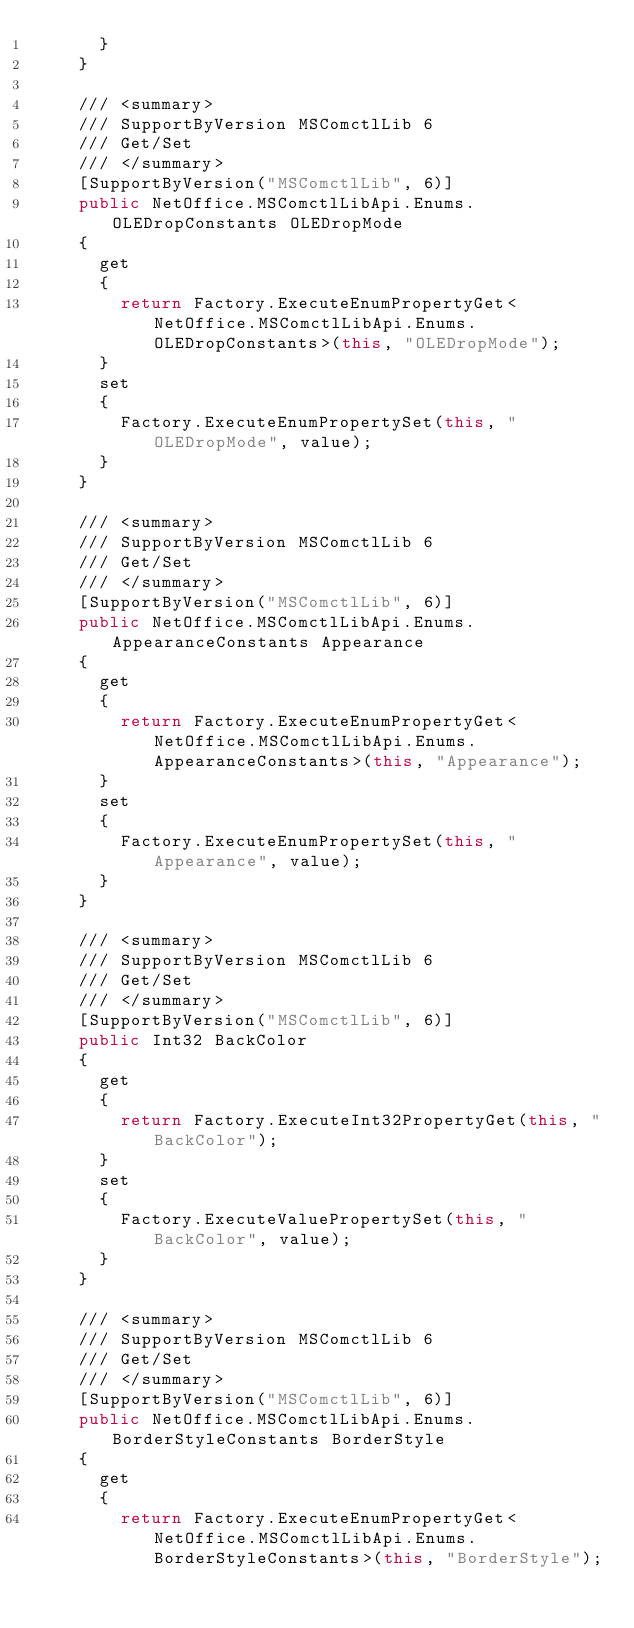<code> <loc_0><loc_0><loc_500><loc_500><_C#_>			}
		}

		/// <summary>
		/// SupportByVersion MSComctlLib 6
		/// Get/Set
		/// </summary>
		[SupportByVersion("MSComctlLib", 6)]
		public NetOffice.MSComctlLibApi.Enums.OLEDropConstants OLEDropMode
		{
			get
			{
				return Factory.ExecuteEnumPropertyGet<NetOffice.MSComctlLibApi.Enums.OLEDropConstants>(this, "OLEDropMode");
			}
			set
			{
				Factory.ExecuteEnumPropertySet(this, "OLEDropMode", value);
			}
		}

		/// <summary>
		/// SupportByVersion MSComctlLib 6
		/// Get/Set
		/// </summary>
		[SupportByVersion("MSComctlLib", 6)]
		public NetOffice.MSComctlLibApi.Enums.AppearanceConstants Appearance
		{
			get
			{
				return Factory.ExecuteEnumPropertyGet<NetOffice.MSComctlLibApi.Enums.AppearanceConstants>(this, "Appearance");
			}
			set
			{
				Factory.ExecuteEnumPropertySet(this, "Appearance", value);
			}
		}

		/// <summary>
		/// SupportByVersion MSComctlLib 6
		/// Get/Set
		/// </summary>
		[SupportByVersion("MSComctlLib", 6)]
		public Int32 BackColor
		{
			get
			{
				return Factory.ExecuteInt32PropertyGet(this, "BackColor");
			}
			set
			{
				Factory.ExecuteValuePropertySet(this, "BackColor", value);
			}
		}

		/// <summary>
		/// SupportByVersion MSComctlLib 6
		/// Get/Set
		/// </summary>
		[SupportByVersion("MSComctlLib", 6)]
		public NetOffice.MSComctlLibApi.Enums.BorderStyleConstants BorderStyle
		{
			get
			{
				return Factory.ExecuteEnumPropertyGet<NetOffice.MSComctlLibApi.Enums.BorderStyleConstants>(this, "BorderStyle");</code> 